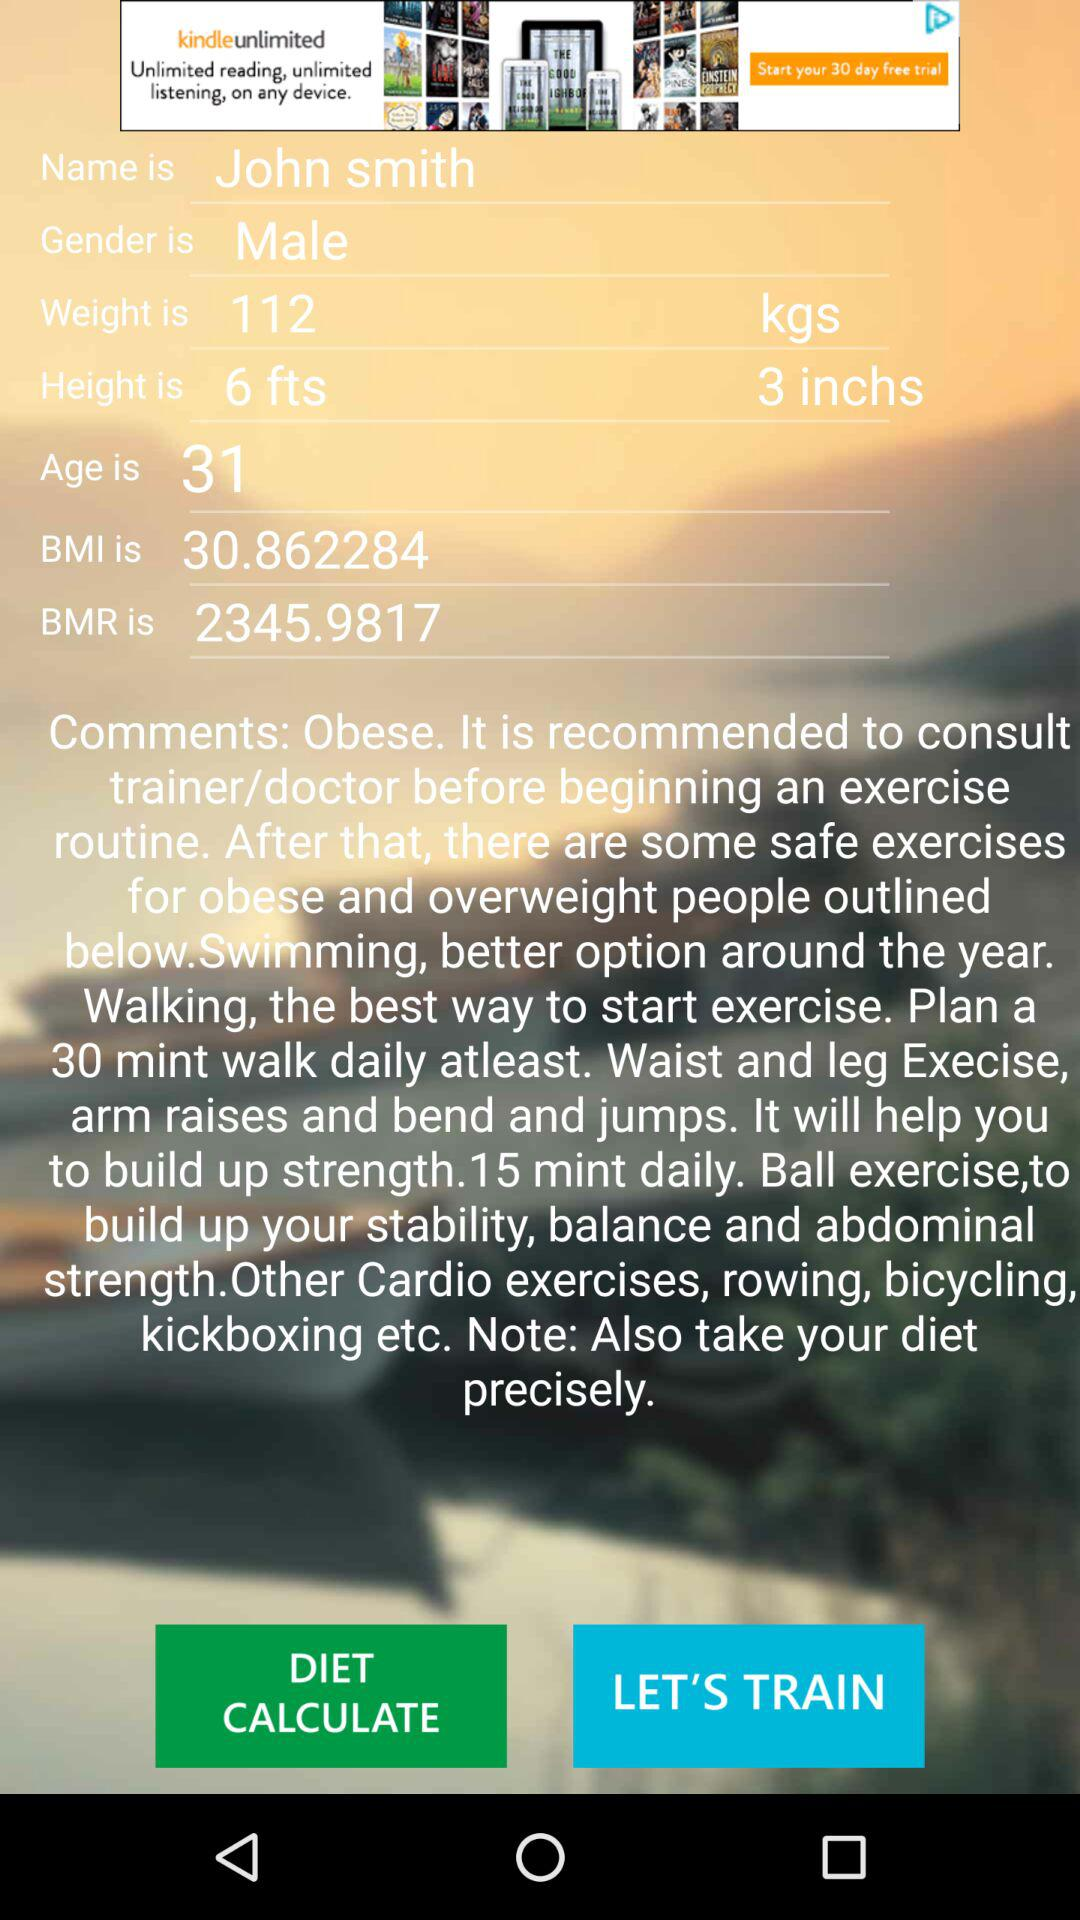What is the gender? The gender is male. 